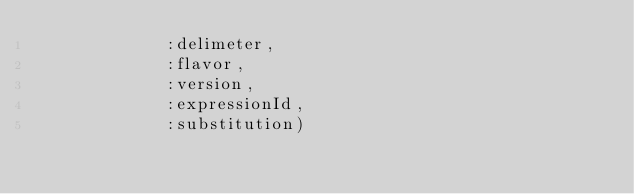<code> <loc_0><loc_0><loc_500><loc_500><_SQL_>             :delimeter,
             :flavor,
             :version,
             :expressionId,
             :substitution)
</code> 